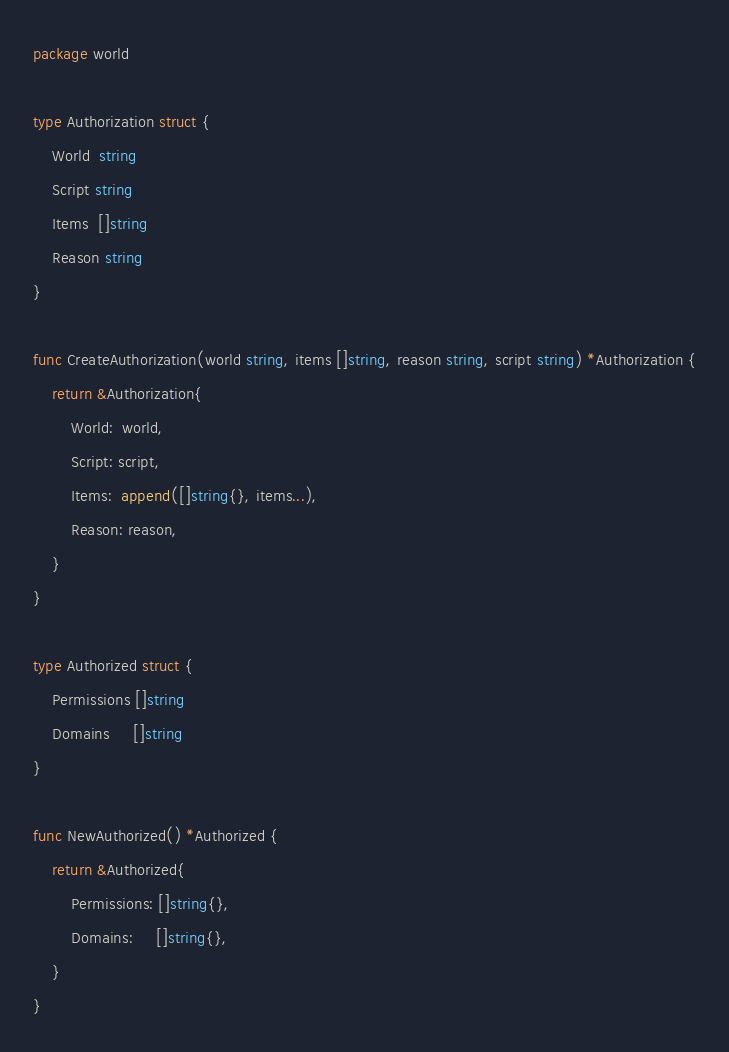Convert code to text. <code><loc_0><loc_0><loc_500><loc_500><_Go_>package world

type Authorization struct {
	World  string
	Script string
	Items  []string
	Reason string
}

func CreateAuthorization(world string, items []string, reason string, script string) *Authorization {
	return &Authorization{
		World:  world,
		Script: script,
		Items:  append([]string{}, items...),
		Reason: reason,
	}
}

type Authorized struct {
	Permissions []string
	Domains     []string
}

func NewAuthorized() *Authorized {
	return &Authorized{
		Permissions: []string{},
		Domains:     []string{},
	}
}
</code> 